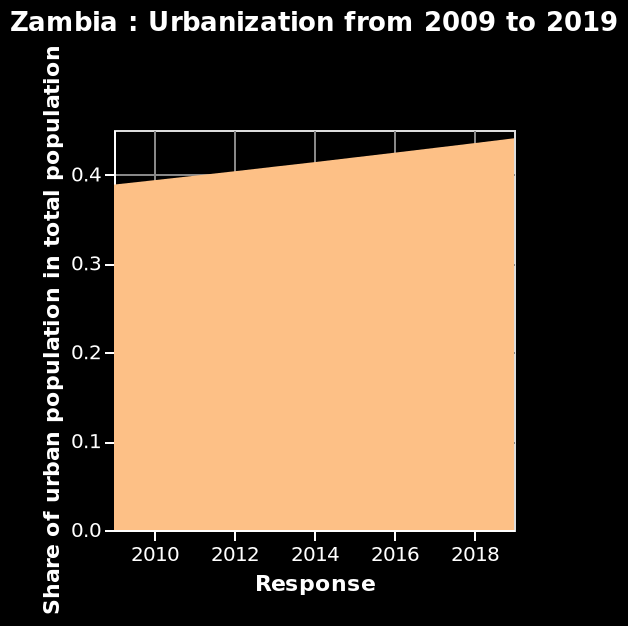<image>
What is the name of the area plot? The area plot is called "Zambia: Urbanization from 2009 to 2019." 